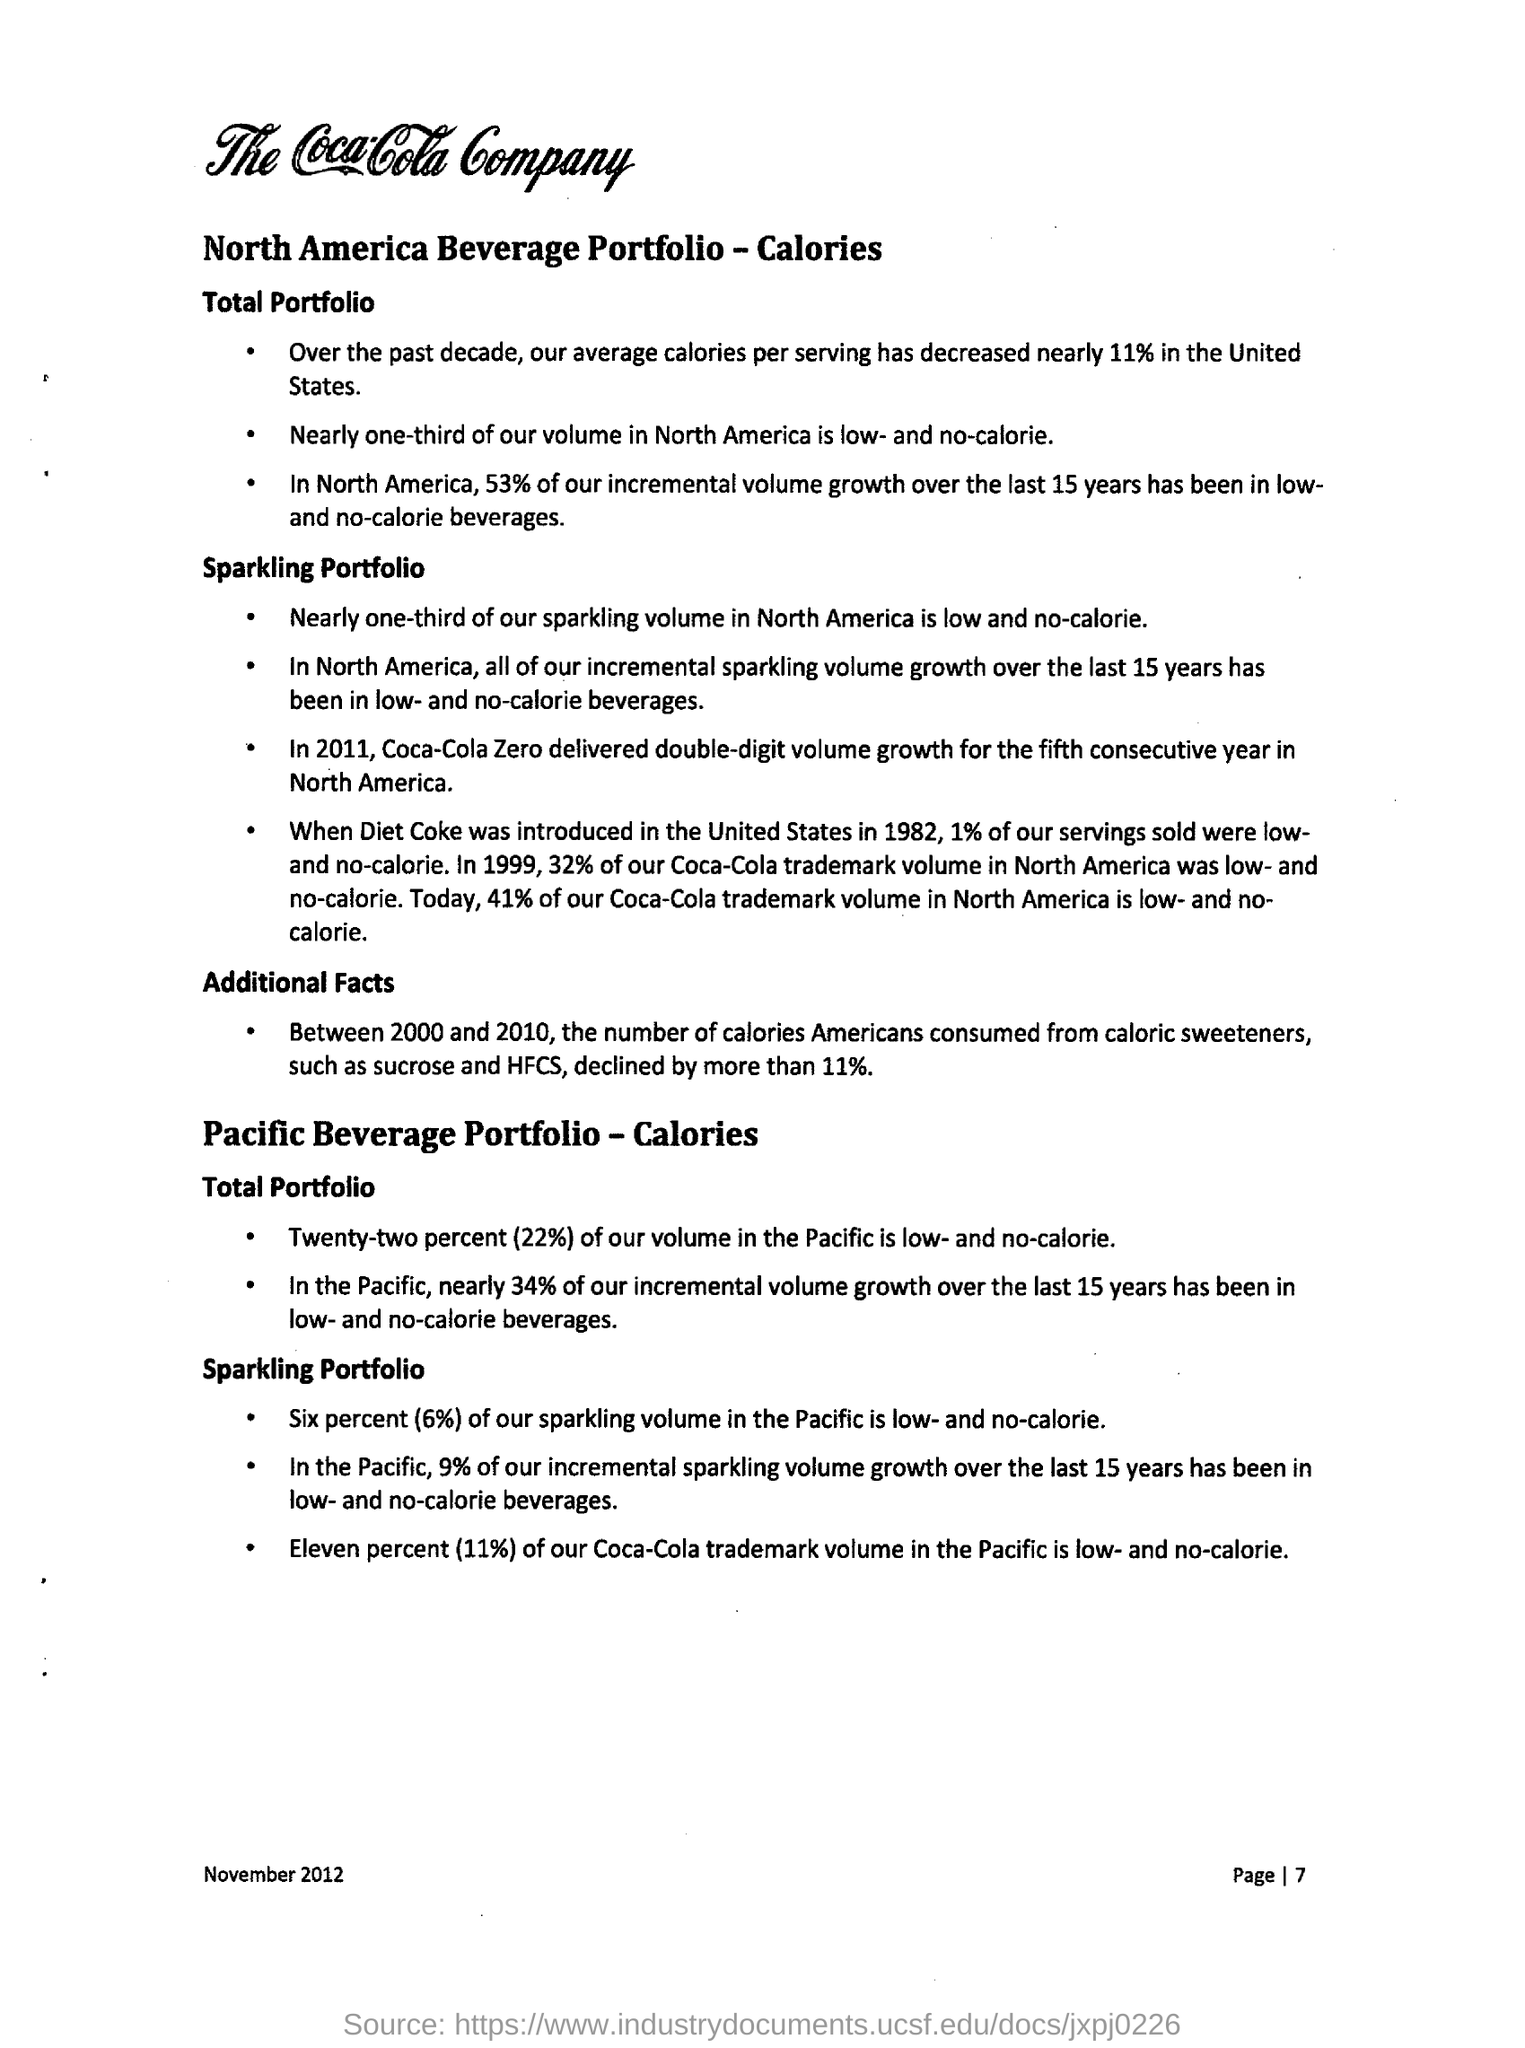What is the average calories decreased over the past decade in the United States?
Offer a very short reply. 11%. In which year diet coke was introduced in United States?
Provide a short and direct response. 1982. What is the percentage decline in the number of calories americans consumed from caloric sweeteners between 2000 and 2010?
Provide a short and direct response. More than 11%. 